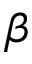<formula> <loc_0><loc_0><loc_500><loc_500>\beta</formula> 